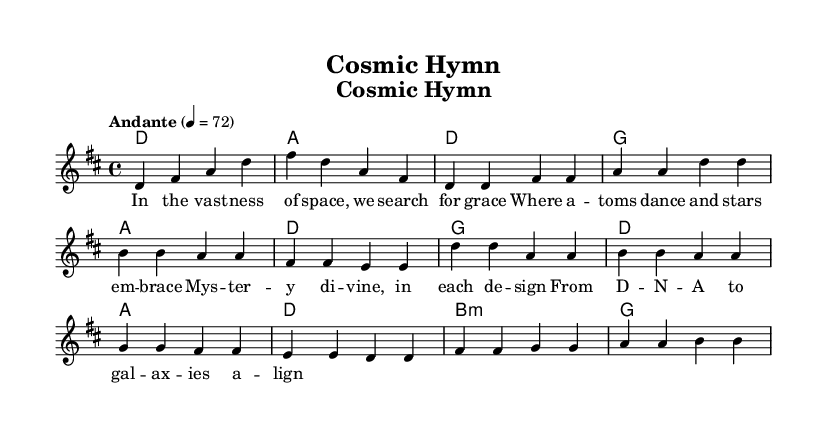What is the key signature of this music? The key signature is indicated by the presence of two sharps, which correspond to F# and C#. This is identified at the beginning of the score in the key signature section.
Answer: D major What is the time signature of this music? The time signature appears at the beginning of the score, indicated as 4/4, which means there are four beats in each measure and the quarter note gets one beat.
Answer: 4/4 What is the tempo marking for this piece? The tempo is indicated in the score as "Andante," which suggests a moderate pace, typically around 76-108 beats per minute. It is explicitly stated above the staff.
Answer: Andante How many lines are in the treble staff of this composition? A treble staff consists of five lines. In the score, we can visually confirm the presence of five horizontal lines that make up the staff.
Answer: Five What is the predominant theme reflected in the lyrics? By examining the lyrics section, which includes lines such as "In the vastness of space" and "Mysterious divine," it is clear that the lyrics reflect themes of wonder, spirituality, and the cosmos.
Answer: Wonder and spirituality How does the chord structure support the theme of the song? The chord structure consists of major chords like D, G, and A, which create a bright and uplifting sound, reinforcing the contemplative and divine themes in the lyrics. The use of major chords often conveys feelings of hope and positivity, aligning with the spiritual exploration of the music.
Answer: Major chords What is the relationship between the verses and the chorus in the context of the song? The verses provide a narrative about searching for grace in the universe, while the chorus reflects on the divine mystery in creation, linking the two sections through thematic development that explores both the scientific and spiritual realms. This cohesive relationship deepens the listener's understanding of the themes presented.
Answer: Thematic development 